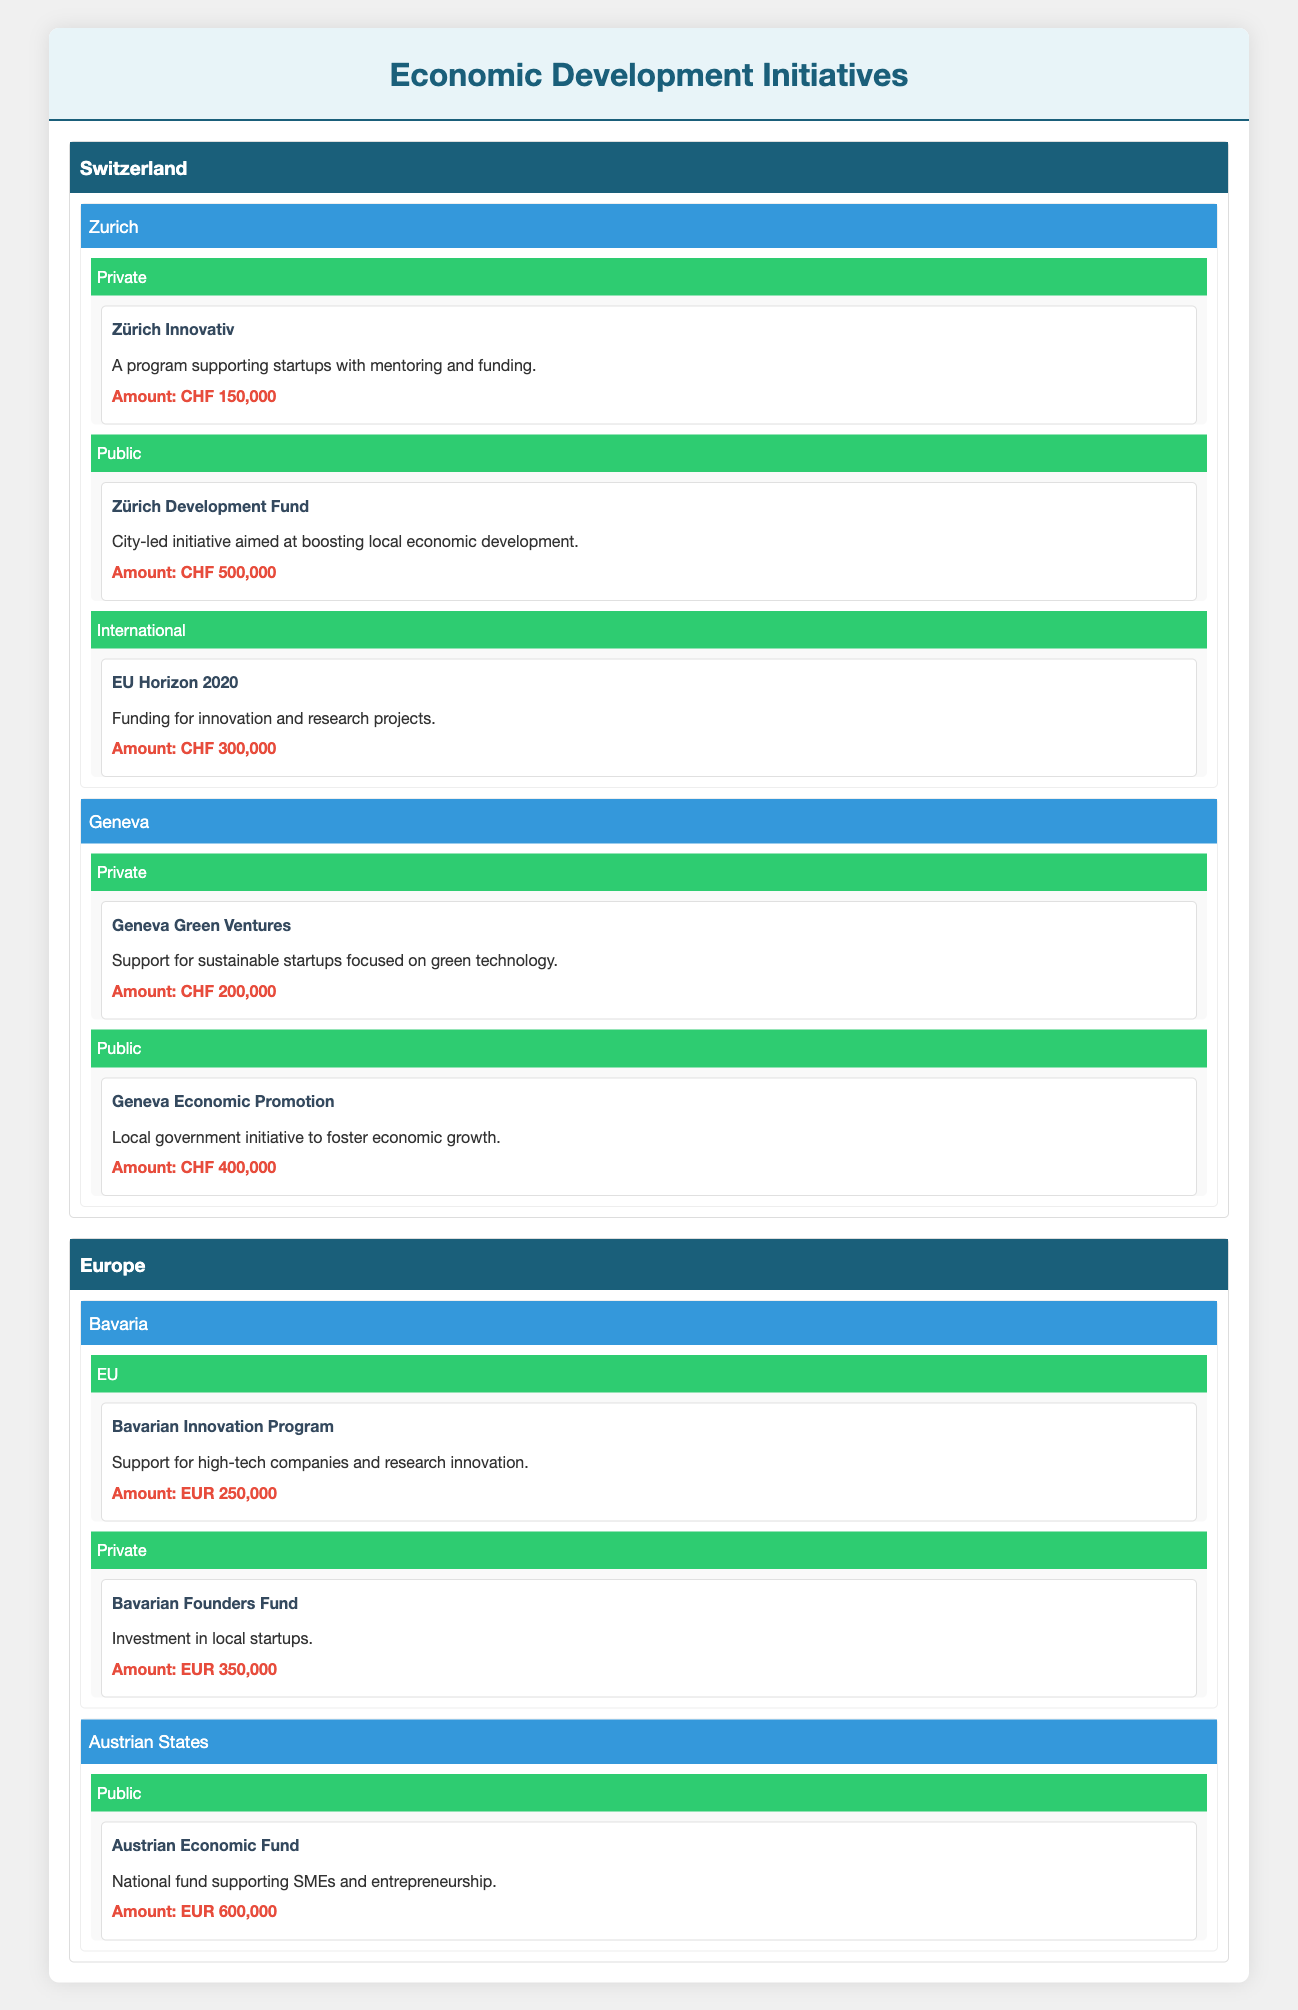What is the total funding amount for initiatives in Zurich? In Zurich, the funding amounts are CHF 150,000 for Zürich Innovativ, CHF 500,000 for Zürich Development Fund, and CHF 300,000 for EU Horizon 2020. Summing these amounts gives 150,000 + 500,000 + 300,000 = 950,000.
Answer: 950,000 Which initiative in Geneva received private funding? The initiative that received private funding in Geneva is "Geneva Green Ventures". According to the table, it is focused on sustainable startups with an amount of CHF 200,000.
Answer: Geneva Green Ventures Is there any public funding initiative in the Austrian States? Yes, there is a public funding initiative in the Austrian States called the "Austrian Economic Fund". It supports SMEs and entrepreneurship and has an amount of EUR 600,000.
Answer: Yes What is the total funding amount from private sources in Switzerland (specifically Zurich and Geneva)? In Switzerland, the total funding amount from private sources includes CHF 150,000 for Zürich Innovativ and CHF 200,000 for Geneva Green Ventures. Summing these gives 150,000 + 200,000 = 350,000.
Answer: 350,000 How many initiatives are funded by public sources in Zurich? There is one public funding initiative in Zurich, which is the "Zürich Development Fund". It aims to boost local economic development.
Answer: 1 Which region has the highest total funding amount, Switzerland or Europe? In Switzerland, the total funding amounts to CHF 950,000 (Zurich) + CHF 600,000 (Geneva) = CHF 1,550,000. In Europe, the total funding is EUR 250,000 (Bavarian Innovation Program) + EUR 350,000 (Bavarian Founders Fund) + EUR 600,000 (Austrian Economic Fund) = EUR 1,200,000. Converting CHF 1,550,000 to EUR (approximately 1 CHF = 0.93 EUR) gives EUR 1,444,500. As 1,444,500 EUR is greater than 1,200,000 EUR, Switzerland has the higher total funding amount.
Answer: Switzerland Are there any international funding initiatives listed in Switzerland? Yes, there is one international funding initiative listed in Switzerland, which is "EU Horizon 2020" with an amount of CHF 300,000.
Answer: Yes 